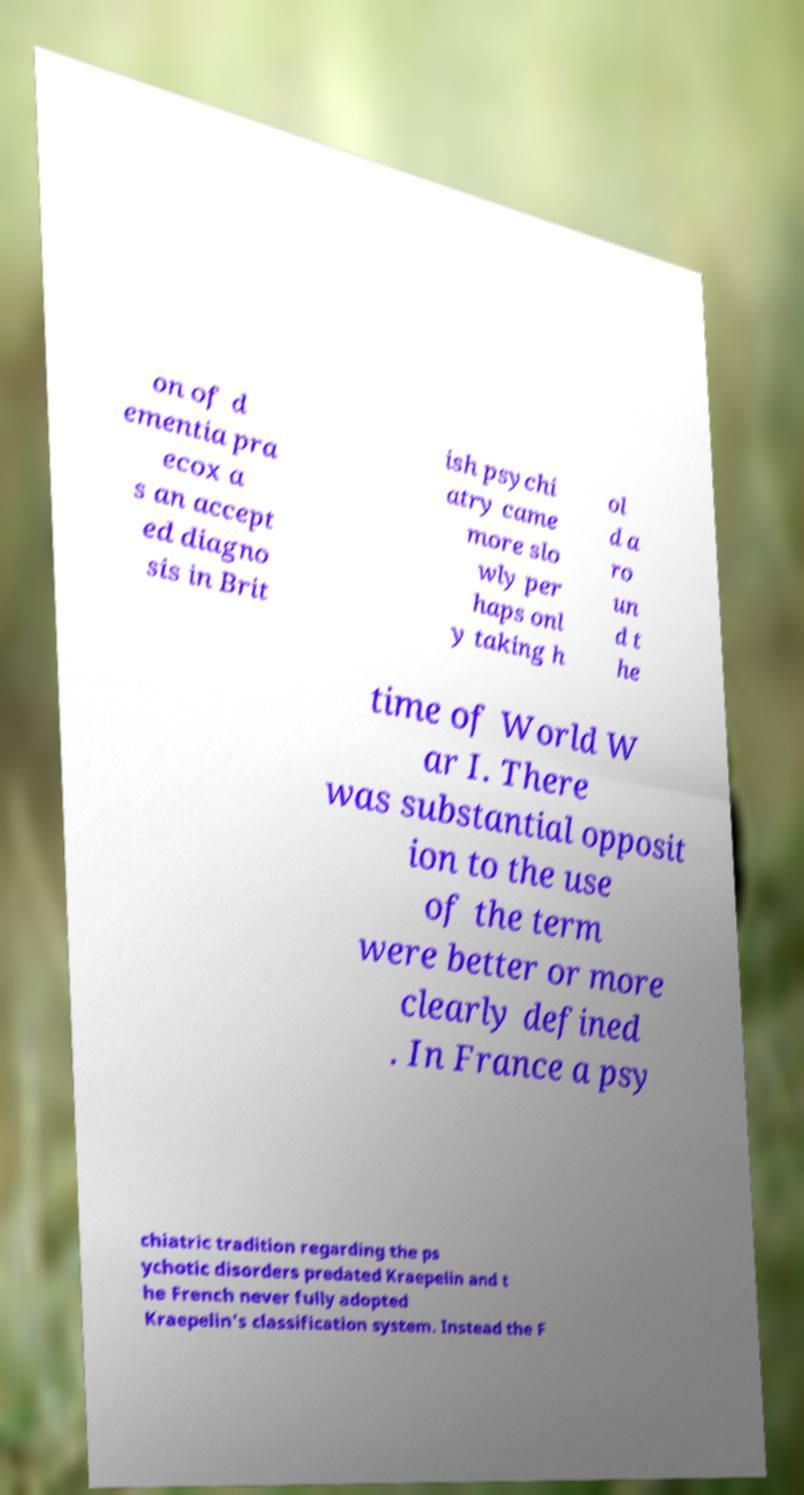Please read and relay the text visible in this image. What does it say? on of d ementia pra ecox a s an accept ed diagno sis in Brit ish psychi atry came more slo wly per haps onl y taking h ol d a ro un d t he time of World W ar I. There was substantial opposit ion to the use of the term were better or more clearly defined . In France a psy chiatric tradition regarding the ps ychotic disorders predated Kraepelin and t he French never fully adopted Kraepelin's classification system. Instead the F 